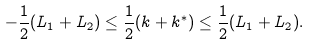<formula> <loc_0><loc_0><loc_500><loc_500>- \frac { 1 } { 2 } ( L _ { 1 } + L _ { 2 } ) \leq \frac { 1 } { 2 } ( k + k ^ { \ast } ) \leq \frac { 1 } { 2 } ( L _ { 1 } + L _ { 2 } ) .</formula> 